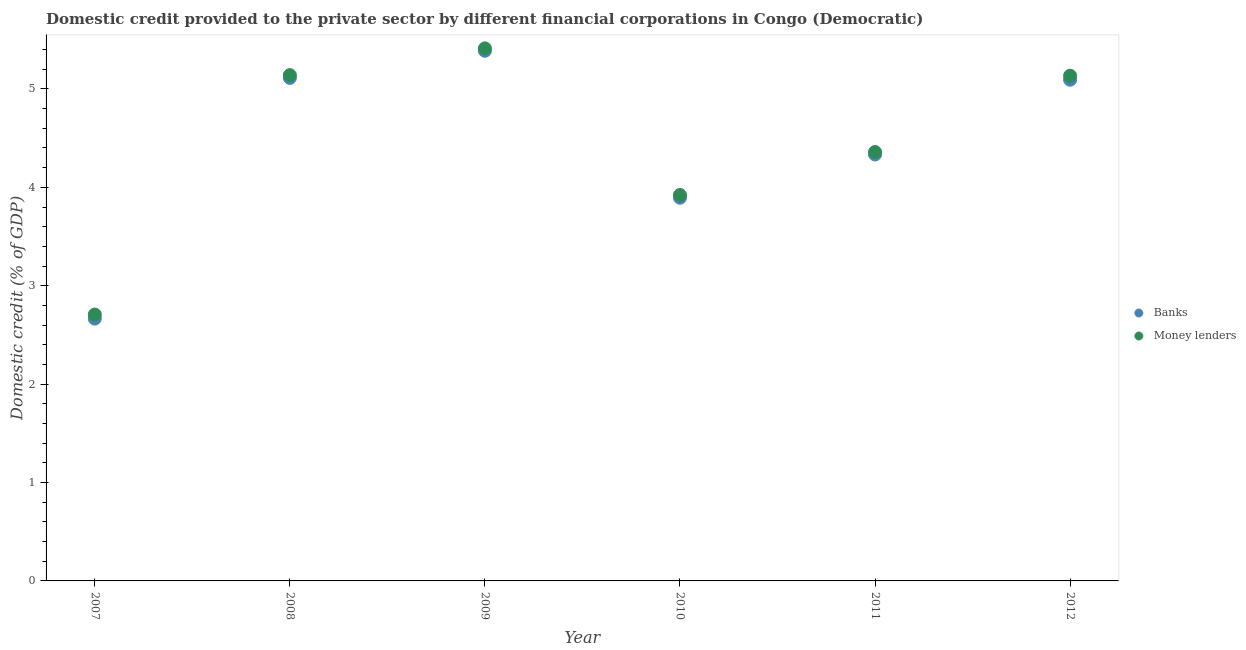What is the domestic credit provided by money lenders in 2008?
Offer a very short reply. 5.14. Across all years, what is the maximum domestic credit provided by money lenders?
Ensure brevity in your answer.  5.41. Across all years, what is the minimum domestic credit provided by money lenders?
Make the answer very short. 2.71. What is the total domestic credit provided by money lenders in the graph?
Your answer should be very brief. 26.67. What is the difference between the domestic credit provided by money lenders in 2008 and that in 2012?
Keep it short and to the point. 0.01. What is the difference between the domestic credit provided by banks in 2010 and the domestic credit provided by money lenders in 2009?
Ensure brevity in your answer.  -1.52. What is the average domestic credit provided by banks per year?
Ensure brevity in your answer.  4.41. In the year 2011, what is the difference between the domestic credit provided by money lenders and domestic credit provided by banks?
Give a very brief answer. 0.02. In how many years, is the domestic credit provided by money lenders greater than 2.8 %?
Offer a terse response. 5. What is the ratio of the domestic credit provided by banks in 2007 to that in 2009?
Make the answer very short. 0.49. What is the difference between the highest and the second highest domestic credit provided by banks?
Your answer should be very brief. 0.28. What is the difference between the highest and the lowest domestic credit provided by banks?
Offer a terse response. 2.72. Does the domestic credit provided by money lenders monotonically increase over the years?
Give a very brief answer. No. Is the domestic credit provided by banks strictly less than the domestic credit provided by money lenders over the years?
Provide a succinct answer. Yes. How many dotlines are there?
Offer a very short reply. 2. How many years are there in the graph?
Keep it short and to the point. 6. What is the difference between two consecutive major ticks on the Y-axis?
Give a very brief answer. 1. How are the legend labels stacked?
Your answer should be compact. Vertical. What is the title of the graph?
Offer a very short reply. Domestic credit provided to the private sector by different financial corporations in Congo (Democratic). What is the label or title of the X-axis?
Offer a very short reply. Year. What is the label or title of the Y-axis?
Your answer should be compact. Domestic credit (% of GDP). What is the Domestic credit (% of GDP) of Banks in 2007?
Your response must be concise. 2.67. What is the Domestic credit (% of GDP) of Money lenders in 2007?
Ensure brevity in your answer.  2.71. What is the Domestic credit (% of GDP) of Banks in 2008?
Offer a very short reply. 5.11. What is the Domestic credit (% of GDP) of Money lenders in 2008?
Offer a very short reply. 5.14. What is the Domestic credit (% of GDP) in Banks in 2009?
Your answer should be very brief. 5.39. What is the Domestic credit (% of GDP) in Money lenders in 2009?
Your answer should be compact. 5.41. What is the Domestic credit (% of GDP) in Banks in 2010?
Offer a terse response. 3.89. What is the Domestic credit (% of GDP) in Money lenders in 2010?
Provide a short and direct response. 3.92. What is the Domestic credit (% of GDP) in Banks in 2011?
Make the answer very short. 4.33. What is the Domestic credit (% of GDP) of Money lenders in 2011?
Provide a succinct answer. 4.36. What is the Domestic credit (% of GDP) in Banks in 2012?
Your answer should be compact. 5.09. What is the Domestic credit (% of GDP) in Money lenders in 2012?
Give a very brief answer. 5.13. Across all years, what is the maximum Domestic credit (% of GDP) in Banks?
Give a very brief answer. 5.39. Across all years, what is the maximum Domestic credit (% of GDP) in Money lenders?
Offer a very short reply. 5.41. Across all years, what is the minimum Domestic credit (% of GDP) in Banks?
Your answer should be compact. 2.67. Across all years, what is the minimum Domestic credit (% of GDP) of Money lenders?
Your answer should be compact. 2.71. What is the total Domestic credit (% of GDP) of Banks in the graph?
Provide a succinct answer. 26.49. What is the total Domestic credit (% of GDP) of Money lenders in the graph?
Offer a terse response. 26.67. What is the difference between the Domestic credit (% of GDP) in Banks in 2007 and that in 2008?
Give a very brief answer. -2.45. What is the difference between the Domestic credit (% of GDP) of Money lenders in 2007 and that in 2008?
Ensure brevity in your answer.  -2.43. What is the difference between the Domestic credit (% of GDP) in Banks in 2007 and that in 2009?
Offer a very short reply. -2.72. What is the difference between the Domestic credit (% of GDP) in Money lenders in 2007 and that in 2009?
Your answer should be compact. -2.7. What is the difference between the Domestic credit (% of GDP) in Banks in 2007 and that in 2010?
Make the answer very short. -1.23. What is the difference between the Domestic credit (% of GDP) of Money lenders in 2007 and that in 2010?
Provide a short and direct response. -1.22. What is the difference between the Domestic credit (% of GDP) in Banks in 2007 and that in 2011?
Keep it short and to the point. -1.67. What is the difference between the Domestic credit (% of GDP) of Money lenders in 2007 and that in 2011?
Make the answer very short. -1.65. What is the difference between the Domestic credit (% of GDP) in Banks in 2007 and that in 2012?
Your answer should be very brief. -2.43. What is the difference between the Domestic credit (% of GDP) in Money lenders in 2007 and that in 2012?
Provide a succinct answer. -2.43. What is the difference between the Domestic credit (% of GDP) in Banks in 2008 and that in 2009?
Ensure brevity in your answer.  -0.28. What is the difference between the Domestic credit (% of GDP) of Money lenders in 2008 and that in 2009?
Provide a succinct answer. -0.27. What is the difference between the Domestic credit (% of GDP) of Banks in 2008 and that in 2010?
Ensure brevity in your answer.  1.22. What is the difference between the Domestic credit (% of GDP) in Money lenders in 2008 and that in 2010?
Your answer should be very brief. 1.22. What is the difference between the Domestic credit (% of GDP) in Banks in 2008 and that in 2011?
Make the answer very short. 0.78. What is the difference between the Domestic credit (% of GDP) of Money lenders in 2008 and that in 2011?
Your response must be concise. 0.78. What is the difference between the Domestic credit (% of GDP) of Banks in 2008 and that in 2012?
Provide a succinct answer. 0.02. What is the difference between the Domestic credit (% of GDP) of Money lenders in 2008 and that in 2012?
Provide a succinct answer. 0.01. What is the difference between the Domestic credit (% of GDP) of Banks in 2009 and that in 2010?
Make the answer very short. 1.49. What is the difference between the Domestic credit (% of GDP) in Money lenders in 2009 and that in 2010?
Your answer should be very brief. 1.49. What is the difference between the Domestic credit (% of GDP) in Banks in 2009 and that in 2011?
Give a very brief answer. 1.05. What is the difference between the Domestic credit (% of GDP) in Money lenders in 2009 and that in 2011?
Provide a succinct answer. 1.05. What is the difference between the Domestic credit (% of GDP) in Banks in 2009 and that in 2012?
Your response must be concise. 0.29. What is the difference between the Domestic credit (% of GDP) of Money lenders in 2009 and that in 2012?
Provide a succinct answer. 0.28. What is the difference between the Domestic credit (% of GDP) of Banks in 2010 and that in 2011?
Make the answer very short. -0.44. What is the difference between the Domestic credit (% of GDP) of Money lenders in 2010 and that in 2011?
Ensure brevity in your answer.  -0.44. What is the difference between the Domestic credit (% of GDP) of Banks in 2010 and that in 2012?
Ensure brevity in your answer.  -1.2. What is the difference between the Domestic credit (% of GDP) in Money lenders in 2010 and that in 2012?
Make the answer very short. -1.21. What is the difference between the Domestic credit (% of GDP) in Banks in 2011 and that in 2012?
Provide a short and direct response. -0.76. What is the difference between the Domestic credit (% of GDP) of Money lenders in 2011 and that in 2012?
Your answer should be compact. -0.78. What is the difference between the Domestic credit (% of GDP) of Banks in 2007 and the Domestic credit (% of GDP) of Money lenders in 2008?
Your response must be concise. -2.47. What is the difference between the Domestic credit (% of GDP) of Banks in 2007 and the Domestic credit (% of GDP) of Money lenders in 2009?
Your answer should be compact. -2.75. What is the difference between the Domestic credit (% of GDP) of Banks in 2007 and the Domestic credit (% of GDP) of Money lenders in 2010?
Ensure brevity in your answer.  -1.26. What is the difference between the Domestic credit (% of GDP) in Banks in 2007 and the Domestic credit (% of GDP) in Money lenders in 2011?
Keep it short and to the point. -1.69. What is the difference between the Domestic credit (% of GDP) in Banks in 2007 and the Domestic credit (% of GDP) in Money lenders in 2012?
Make the answer very short. -2.47. What is the difference between the Domestic credit (% of GDP) of Banks in 2008 and the Domestic credit (% of GDP) of Money lenders in 2009?
Offer a very short reply. -0.3. What is the difference between the Domestic credit (% of GDP) in Banks in 2008 and the Domestic credit (% of GDP) in Money lenders in 2010?
Offer a terse response. 1.19. What is the difference between the Domestic credit (% of GDP) in Banks in 2008 and the Domestic credit (% of GDP) in Money lenders in 2011?
Give a very brief answer. 0.75. What is the difference between the Domestic credit (% of GDP) in Banks in 2008 and the Domestic credit (% of GDP) in Money lenders in 2012?
Ensure brevity in your answer.  -0.02. What is the difference between the Domestic credit (% of GDP) of Banks in 2009 and the Domestic credit (% of GDP) of Money lenders in 2010?
Make the answer very short. 1.47. What is the difference between the Domestic credit (% of GDP) in Banks in 2009 and the Domestic credit (% of GDP) in Money lenders in 2011?
Offer a terse response. 1.03. What is the difference between the Domestic credit (% of GDP) in Banks in 2009 and the Domestic credit (% of GDP) in Money lenders in 2012?
Provide a succinct answer. 0.25. What is the difference between the Domestic credit (% of GDP) in Banks in 2010 and the Domestic credit (% of GDP) in Money lenders in 2011?
Make the answer very short. -0.46. What is the difference between the Domestic credit (% of GDP) in Banks in 2010 and the Domestic credit (% of GDP) in Money lenders in 2012?
Ensure brevity in your answer.  -1.24. What is the difference between the Domestic credit (% of GDP) in Banks in 2011 and the Domestic credit (% of GDP) in Money lenders in 2012?
Provide a short and direct response. -0.8. What is the average Domestic credit (% of GDP) in Banks per year?
Your answer should be compact. 4.41. What is the average Domestic credit (% of GDP) in Money lenders per year?
Ensure brevity in your answer.  4.45. In the year 2007, what is the difference between the Domestic credit (% of GDP) of Banks and Domestic credit (% of GDP) of Money lenders?
Give a very brief answer. -0.04. In the year 2008, what is the difference between the Domestic credit (% of GDP) of Banks and Domestic credit (% of GDP) of Money lenders?
Offer a very short reply. -0.03. In the year 2009, what is the difference between the Domestic credit (% of GDP) of Banks and Domestic credit (% of GDP) of Money lenders?
Make the answer very short. -0.02. In the year 2010, what is the difference between the Domestic credit (% of GDP) of Banks and Domestic credit (% of GDP) of Money lenders?
Your answer should be very brief. -0.03. In the year 2011, what is the difference between the Domestic credit (% of GDP) of Banks and Domestic credit (% of GDP) of Money lenders?
Keep it short and to the point. -0.02. In the year 2012, what is the difference between the Domestic credit (% of GDP) of Banks and Domestic credit (% of GDP) of Money lenders?
Keep it short and to the point. -0.04. What is the ratio of the Domestic credit (% of GDP) in Banks in 2007 to that in 2008?
Your answer should be very brief. 0.52. What is the ratio of the Domestic credit (% of GDP) in Money lenders in 2007 to that in 2008?
Give a very brief answer. 0.53. What is the ratio of the Domestic credit (% of GDP) in Banks in 2007 to that in 2009?
Your response must be concise. 0.49. What is the ratio of the Domestic credit (% of GDP) in Money lenders in 2007 to that in 2009?
Provide a short and direct response. 0.5. What is the ratio of the Domestic credit (% of GDP) of Banks in 2007 to that in 2010?
Offer a very short reply. 0.68. What is the ratio of the Domestic credit (% of GDP) of Money lenders in 2007 to that in 2010?
Make the answer very short. 0.69. What is the ratio of the Domestic credit (% of GDP) of Banks in 2007 to that in 2011?
Keep it short and to the point. 0.62. What is the ratio of the Domestic credit (% of GDP) in Money lenders in 2007 to that in 2011?
Your answer should be very brief. 0.62. What is the ratio of the Domestic credit (% of GDP) in Banks in 2007 to that in 2012?
Your response must be concise. 0.52. What is the ratio of the Domestic credit (% of GDP) of Money lenders in 2007 to that in 2012?
Give a very brief answer. 0.53. What is the ratio of the Domestic credit (% of GDP) in Banks in 2008 to that in 2009?
Your answer should be very brief. 0.95. What is the ratio of the Domestic credit (% of GDP) of Money lenders in 2008 to that in 2009?
Keep it short and to the point. 0.95. What is the ratio of the Domestic credit (% of GDP) in Banks in 2008 to that in 2010?
Your answer should be very brief. 1.31. What is the ratio of the Domestic credit (% of GDP) of Money lenders in 2008 to that in 2010?
Make the answer very short. 1.31. What is the ratio of the Domestic credit (% of GDP) of Banks in 2008 to that in 2011?
Offer a terse response. 1.18. What is the ratio of the Domestic credit (% of GDP) of Money lenders in 2008 to that in 2011?
Offer a terse response. 1.18. What is the ratio of the Domestic credit (% of GDP) of Money lenders in 2008 to that in 2012?
Offer a very short reply. 1. What is the ratio of the Domestic credit (% of GDP) of Banks in 2009 to that in 2010?
Your answer should be compact. 1.38. What is the ratio of the Domestic credit (% of GDP) of Money lenders in 2009 to that in 2010?
Offer a terse response. 1.38. What is the ratio of the Domestic credit (% of GDP) in Banks in 2009 to that in 2011?
Make the answer very short. 1.24. What is the ratio of the Domestic credit (% of GDP) in Money lenders in 2009 to that in 2011?
Ensure brevity in your answer.  1.24. What is the ratio of the Domestic credit (% of GDP) in Banks in 2009 to that in 2012?
Offer a terse response. 1.06. What is the ratio of the Domestic credit (% of GDP) in Money lenders in 2009 to that in 2012?
Your answer should be compact. 1.05. What is the ratio of the Domestic credit (% of GDP) in Banks in 2010 to that in 2011?
Your answer should be compact. 0.9. What is the ratio of the Domestic credit (% of GDP) of Money lenders in 2010 to that in 2011?
Your response must be concise. 0.9. What is the ratio of the Domestic credit (% of GDP) in Banks in 2010 to that in 2012?
Offer a terse response. 0.76. What is the ratio of the Domestic credit (% of GDP) of Money lenders in 2010 to that in 2012?
Your response must be concise. 0.76. What is the ratio of the Domestic credit (% of GDP) of Banks in 2011 to that in 2012?
Your answer should be compact. 0.85. What is the ratio of the Domestic credit (% of GDP) in Money lenders in 2011 to that in 2012?
Make the answer very short. 0.85. What is the difference between the highest and the second highest Domestic credit (% of GDP) of Banks?
Give a very brief answer. 0.28. What is the difference between the highest and the second highest Domestic credit (% of GDP) in Money lenders?
Make the answer very short. 0.27. What is the difference between the highest and the lowest Domestic credit (% of GDP) of Banks?
Your response must be concise. 2.72. What is the difference between the highest and the lowest Domestic credit (% of GDP) of Money lenders?
Your answer should be very brief. 2.7. 